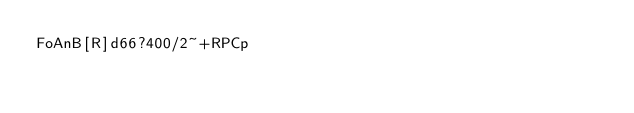<code> <loc_0><loc_0><loc_500><loc_500><_dc_>FoAnB[R]d66?400/2~+RPCp</code> 